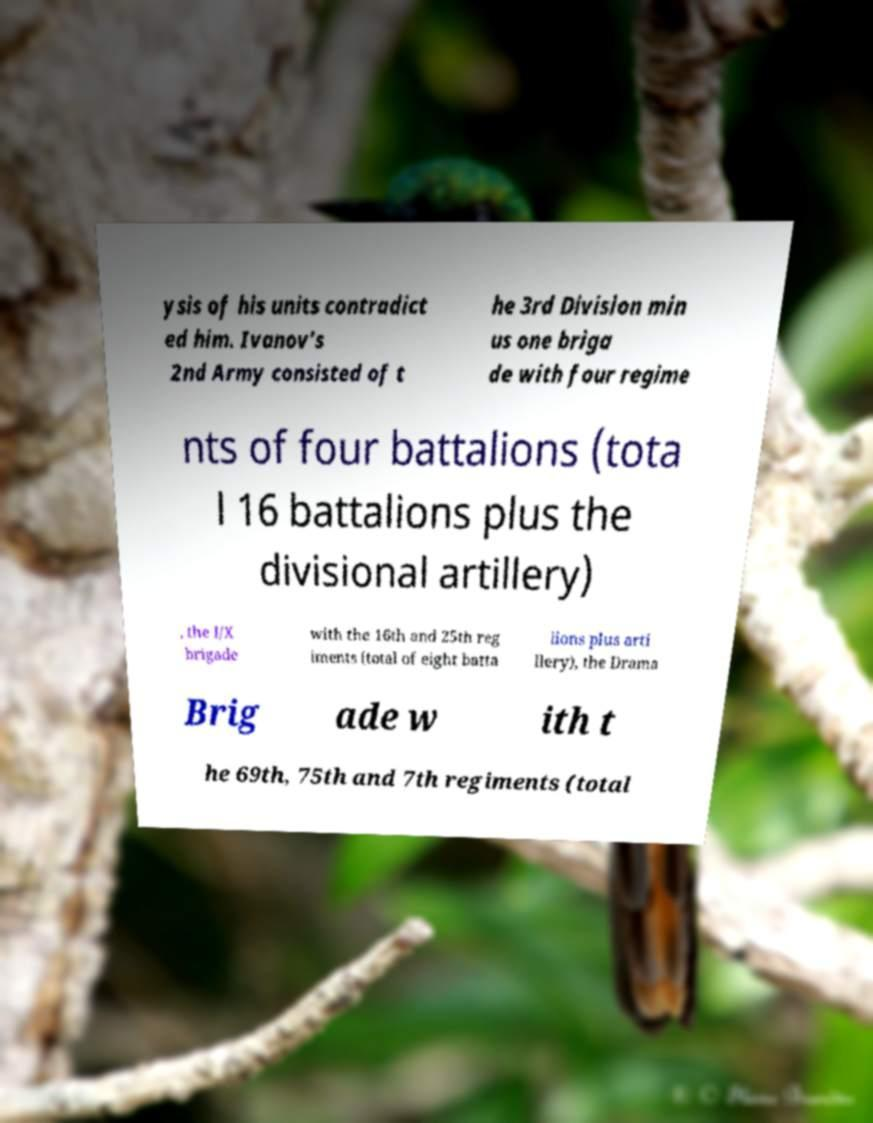Can you accurately transcribe the text from the provided image for me? ysis of his units contradict ed him. Ivanov's 2nd Army consisted of t he 3rd Division min us one briga de with four regime nts of four battalions (tota l 16 battalions plus the divisional artillery) , the I/X brigade with the 16th and 25th reg iments (total of eight batta lions plus arti llery), the Drama Brig ade w ith t he 69th, 75th and 7th regiments (total 